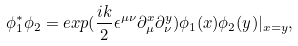Convert formula to latex. <formula><loc_0><loc_0><loc_500><loc_500>\phi _ { 1 } ^ { * } \phi _ { 2 } = e x p ( \frac { i k } { 2 } \epsilon ^ { \mu \nu } \partial _ { \mu } ^ { x } \partial _ { \nu } ^ { y } ) \phi _ { 1 } ( x ) \phi _ { 2 } ( y ) | _ { x = y } ,</formula> 